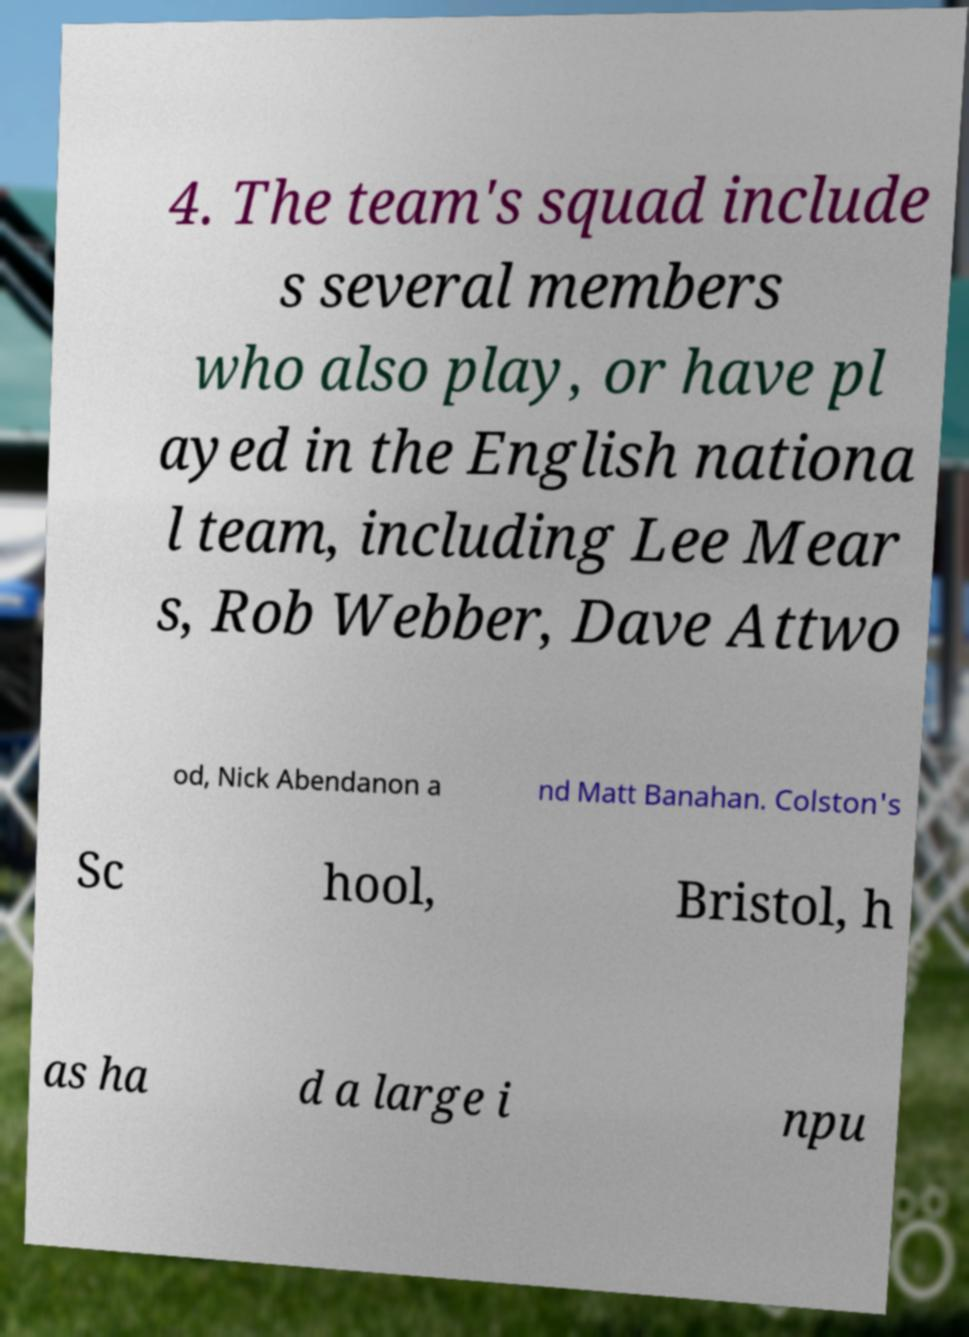What messages or text are displayed in this image? I need them in a readable, typed format. 4. The team's squad include s several members who also play, or have pl ayed in the English nationa l team, including Lee Mear s, Rob Webber, Dave Attwo od, Nick Abendanon a nd Matt Banahan. Colston's Sc hool, Bristol, h as ha d a large i npu 